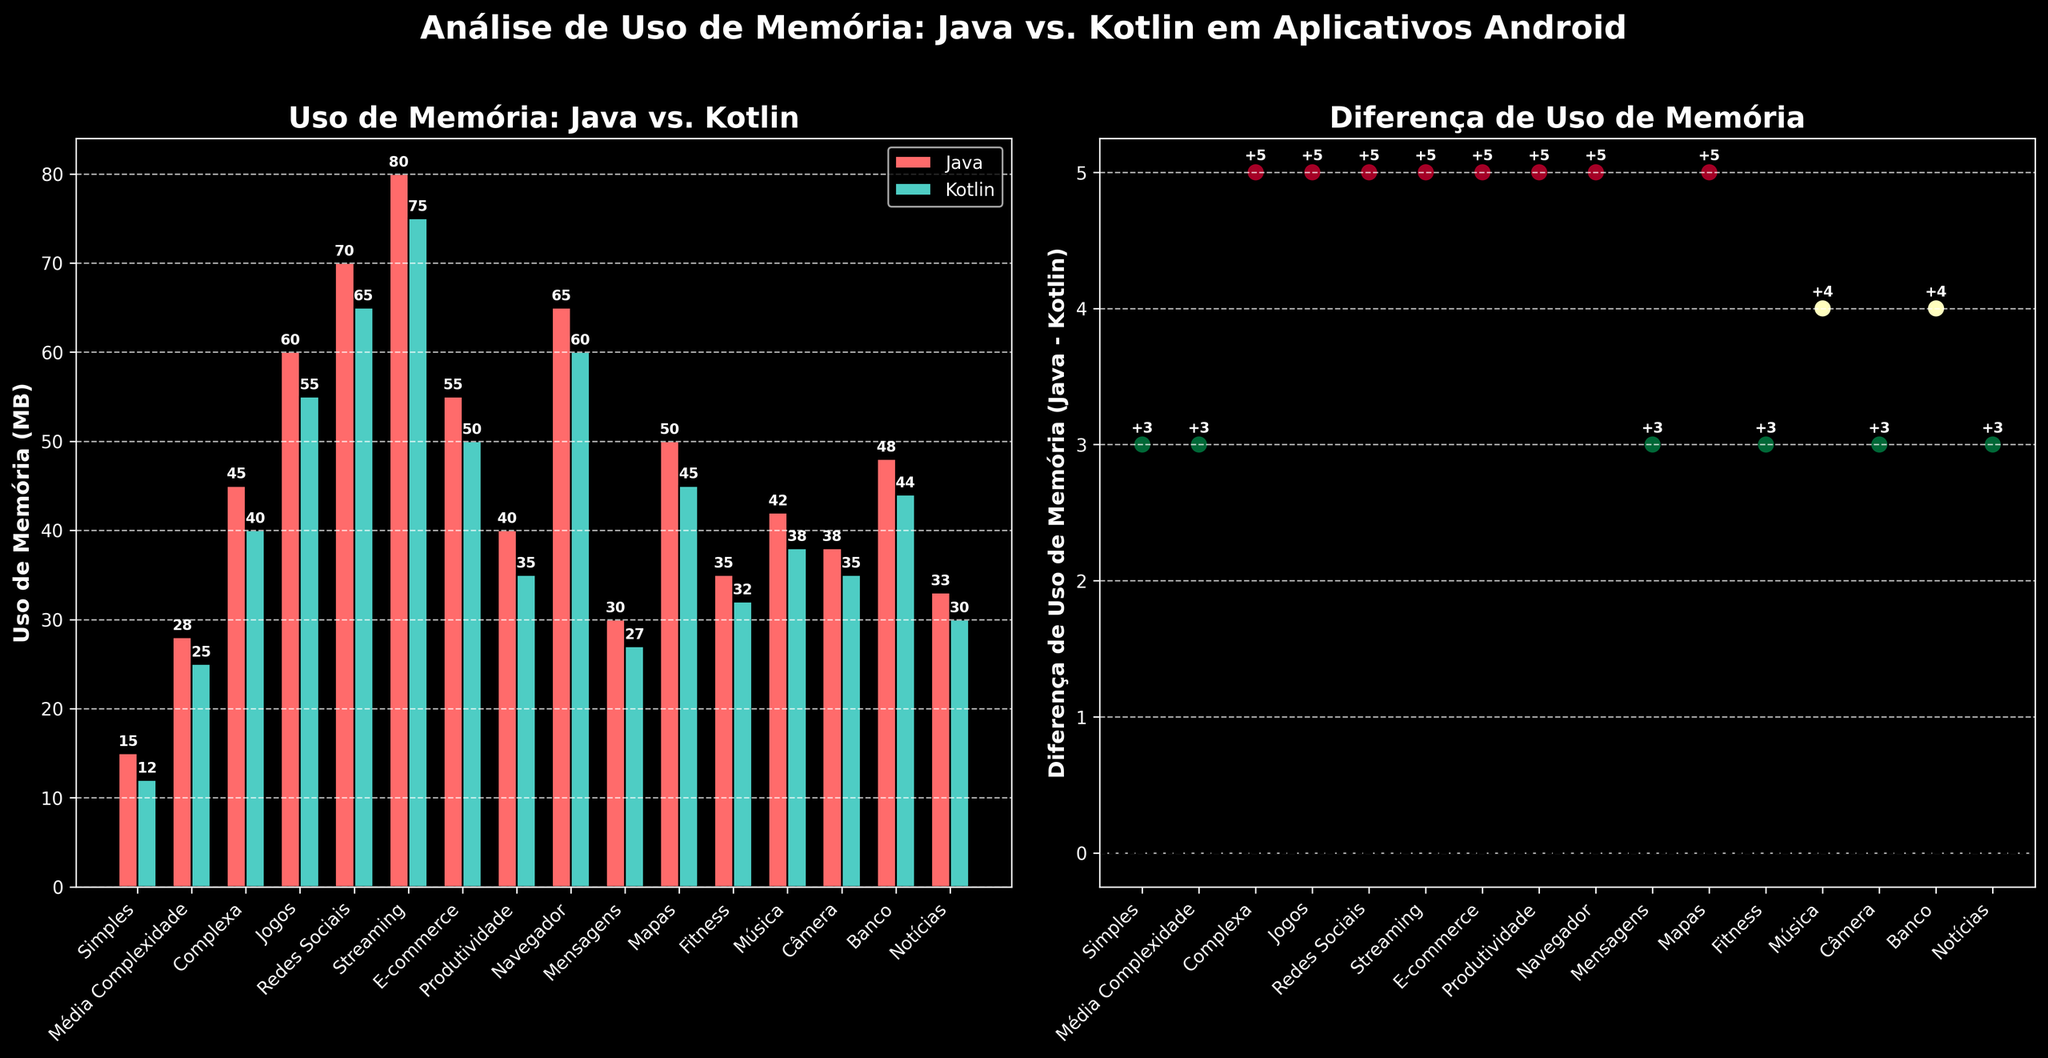What's the average memory usage for apps in Kotlin? To find the average memory usage for Kotlin apps, sum up all memory usages and divide by the number of apps. The total memory usage is 607 MB for 16 apps. The average is 607 / 16 = 37.94 MB.
Answer: 37.94 MB Which type of app has the highest memory usage difference between Java and Kotlin? Look at the "Diferença de Uso de Memória" subplot. The highest positive difference corresponds to the Streaming app, with a difference of +5 MB.
Answer: Streaming Are there any apps where Java and Kotlin have the same memory usage? There are no horizontal lines at zero in the difference plot, indicating no apps have the same memory usage for Java and Kotlin.
Answer: No What is the difference in memory usage between Java and Kotlin for social media apps compared to fitness apps? Social media apps show a +5 MB difference, and fitness apps show a +3 MB difference. The difference is 5 - 3 = 2 MB.
Answer: 2 MB Which app has the lowest memory usage in Kotlin? In the bar chart subplot, the app with the shortest green bar in Kotlin is the "Simples" app with 12 MB.
Answer: Simples (12 MB) What is the average difference in memory usage across all types of apps? To find the average difference, sum up all individual differences and divide by the number of apps. Total difference = 3+3+5+5+5+5+5+5=57MB. Average = 57 / 16 = 3.56 MB.
Answer: 3.56 MB Which apps have a memory usage difference of more than 5 MB between Java and Kotlin? Look at the "Diferença de Uso de Memória" subplot. No apps have differences greater than 5 MB between Java and Kotlin.
Answer: None For which category of apps do Java and Kotlin show the smallest memory usage difference? Look at the "Diferença de Uso de Memória" subplot for the smallest positive or negative vertical displacement from zero. The smallest is +2 MB for "Básico".
Answer: Básico (2 MB) How does the memory usage of Java and Kotlin compare in productivity apps? In the bar chart, the productivity app has a memory usage of 40 MB in Java and 35 MB in Kotlin. Java uses 5 MB more than Kotlin in productivity apps.
Answer: Java uses 5 MB more 